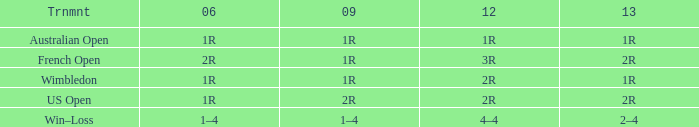What is the 2006 when the 2013 is 1r, and the 2012 is 1r? 1R. 